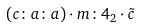<formula> <loc_0><loc_0><loc_500><loc_500>( c \colon a \colon a ) \cdot m \colon 4 _ { 2 } \cdot \tilde { c }</formula> 